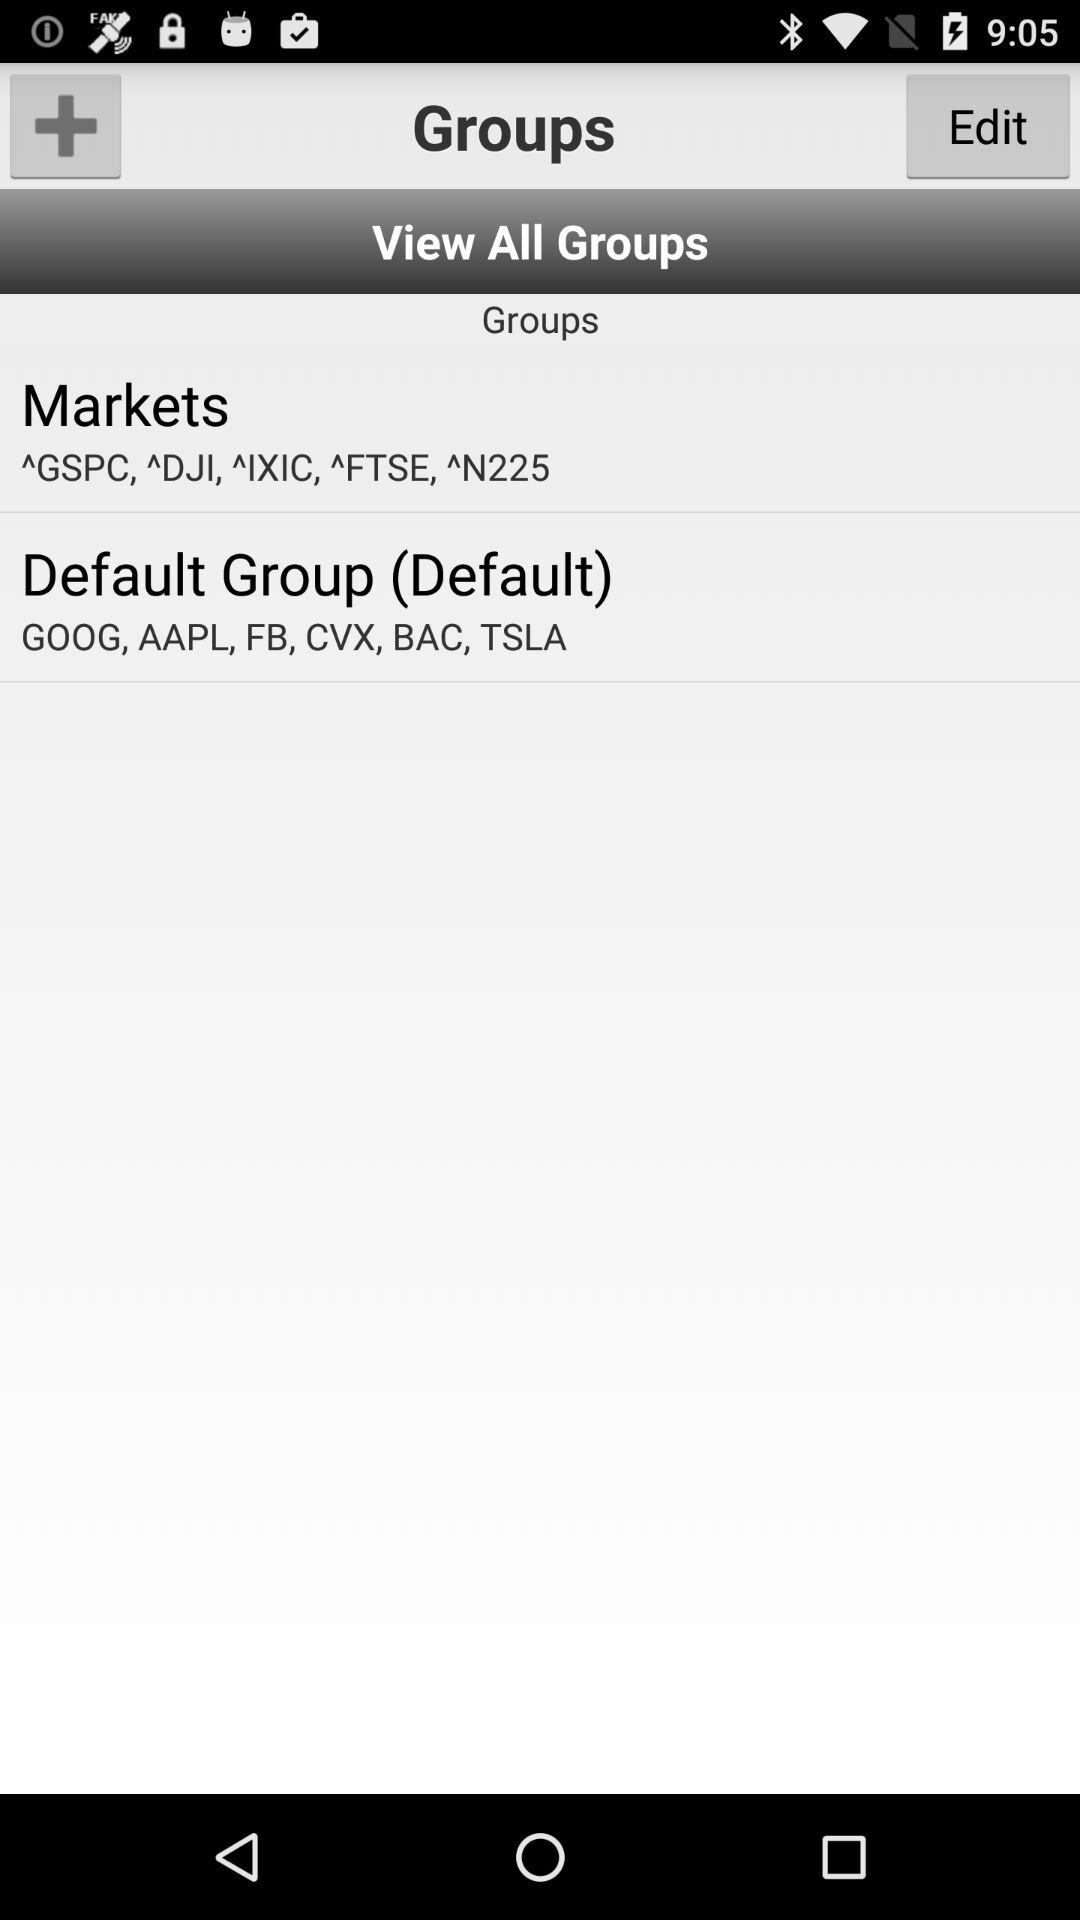How many stocks are in the Default Group?
Answer the question using a single word or phrase. 6 